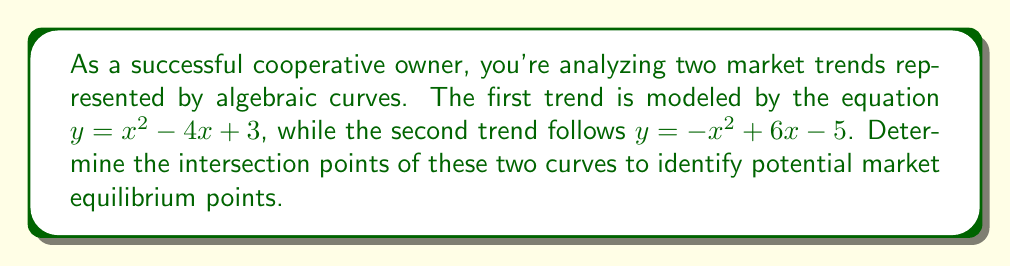Solve this math problem. To find the intersection points of the two curves, we need to solve the system of equations:

$$\begin{cases}
y = x^2 - 4x + 3 \\
y = -x^2 + 6x - 5
\end{cases}$$

Step 1: Set the equations equal to each other since they represent the same y-value at intersection points.
$x^2 - 4x + 3 = -x^2 + 6x - 5$

Step 2: Rearrange the equation to standard form.
$2x^2 - 10x + 8 = 0$

Step 3: Divide all terms by 2 to simplify.
$x^2 - 5x + 4 = 0$

Step 4: Use the quadratic formula to solve for x.
$x = \frac{-b \pm \sqrt{b^2 - 4ac}}{2a}$

Where $a=1$, $b=-5$, and $c=4$

$x = \frac{5 \pm \sqrt{25 - 16}}{2} = \frac{5 \pm 3}{2}$

Step 5: Calculate the two x-values.
$x_1 = \frac{5 + 3}{2} = 4$ and $x_2 = \frac{5 - 3}{2} = 1$

Step 6: Find the corresponding y-values by substituting x into either original equation.
For $x_1 = 4$: $y = 4^2 - 4(4) + 3 = 16 - 16 + 3 = 3$
For $x_2 = 1$: $y = 1^2 - 4(1) + 3 = 1 - 4 + 3 = 0$

Therefore, the intersection points are (4, 3) and (1, 0).
Answer: (4, 3) and (1, 0) 